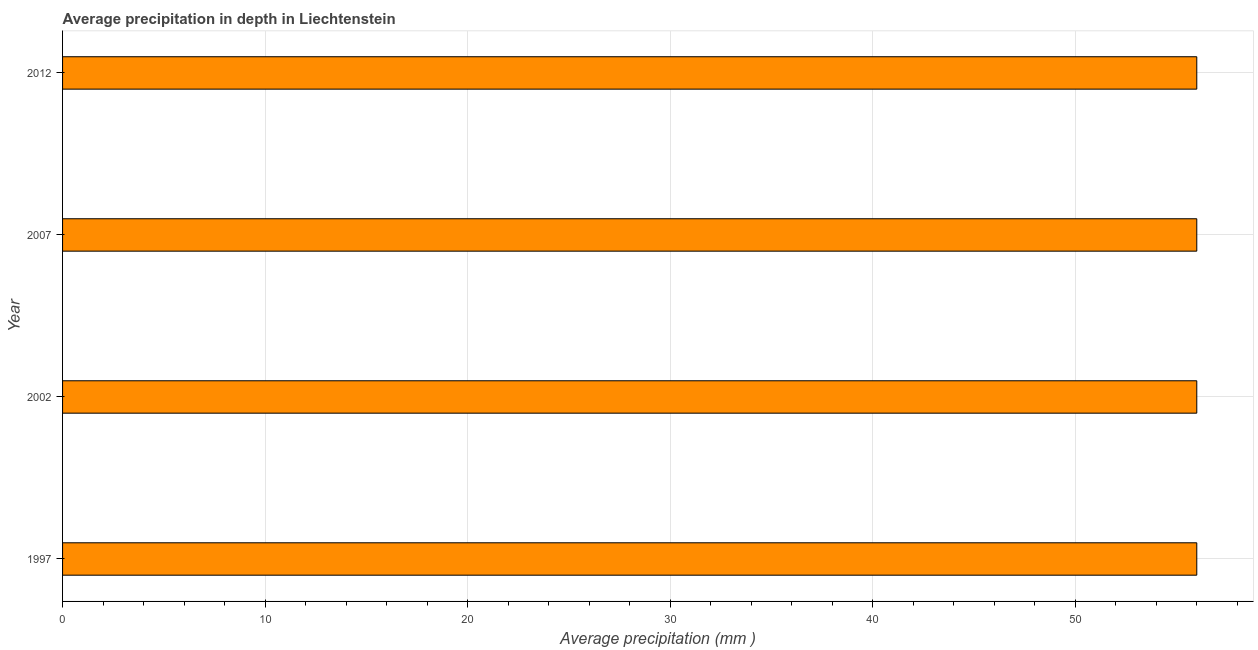What is the title of the graph?
Offer a very short reply. Average precipitation in depth in Liechtenstein. What is the label or title of the X-axis?
Give a very brief answer. Average precipitation (mm ). Across all years, what is the maximum average precipitation in depth?
Your response must be concise. 56. In which year was the average precipitation in depth maximum?
Keep it short and to the point. 1997. In which year was the average precipitation in depth minimum?
Your answer should be compact. 1997. What is the sum of the average precipitation in depth?
Your answer should be very brief. 224. What is the difference between the average precipitation in depth in 1997 and 2007?
Provide a succinct answer. 0. In how many years, is the average precipitation in depth greater than 16 mm?
Keep it short and to the point. 4. What is the ratio of the average precipitation in depth in 1997 to that in 2002?
Your response must be concise. 1. Is the average precipitation in depth in 1997 less than that in 2002?
Your answer should be very brief. No. Is the sum of the average precipitation in depth in 2002 and 2012 greater than the maximum average precipitation in depth across all years?
Make the answer very short. Yes. How many bars are there?
Offer a terse response. 4. How many years are there in the graph?
Keep it short and to the point. 4. What is the difference between two consecutive major ticks on the X-axis?
Your response must be concise. 10. Are the values on the major ticks of X-axis written in scientific E-notation?
Provide a succinct answer. No. What is the Average precipitation (mm ) of 2002?
Your answer should be very brief. 56. What is the difference between the Average precipitation (mm ) in 1997 and 2007?
Your answer should be compact. 0. What is the difference between the Average precipitation (mm ) in 2002 and 2012?
Keep it short and to the point. 0. What is the difference between the Average precipitation (mm ) in 2007 and 2012?
Offer a terse response. 0. What is the ratio of the Average precipitation (mm ) in 1997 to that in 2012?
Offer a terse response. 1. 